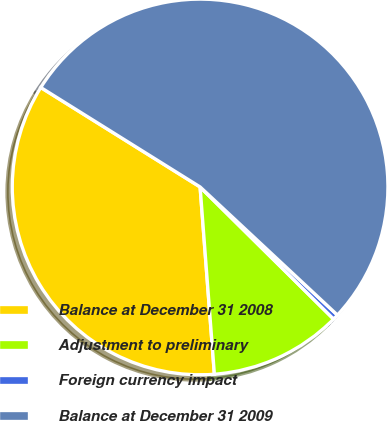<chart> <loc_0><loc_0><loc_500><loc_500><pie_chart><fcel>Balance at December 31 2008<fcel>Adjustment to preliminary<fcel>Foreign currency impact<fcel>Balance at December 31 2009<nl><fcel>35.09%<fcel>11.37%<fcel>0.47%<fcel>53.06%<nl></chart> 